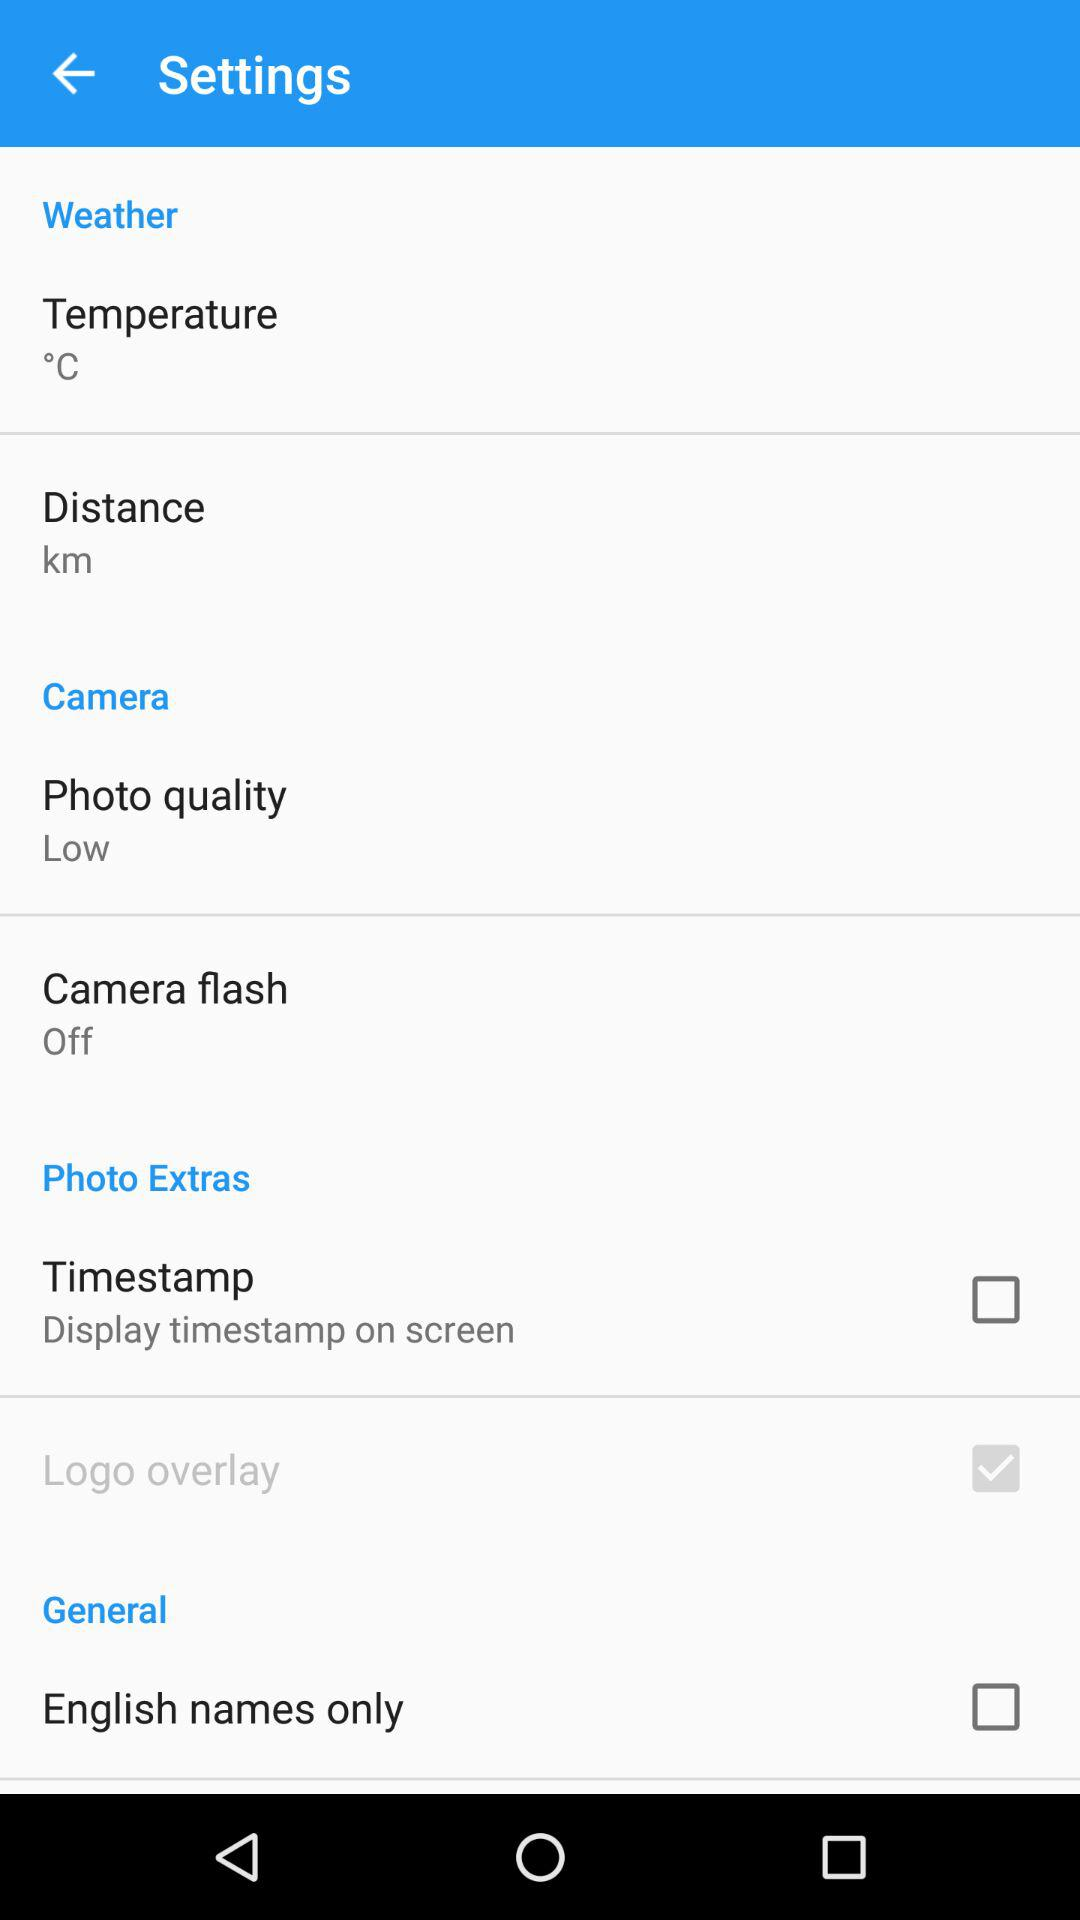What's the photo quality? The photo quality is "Low". 